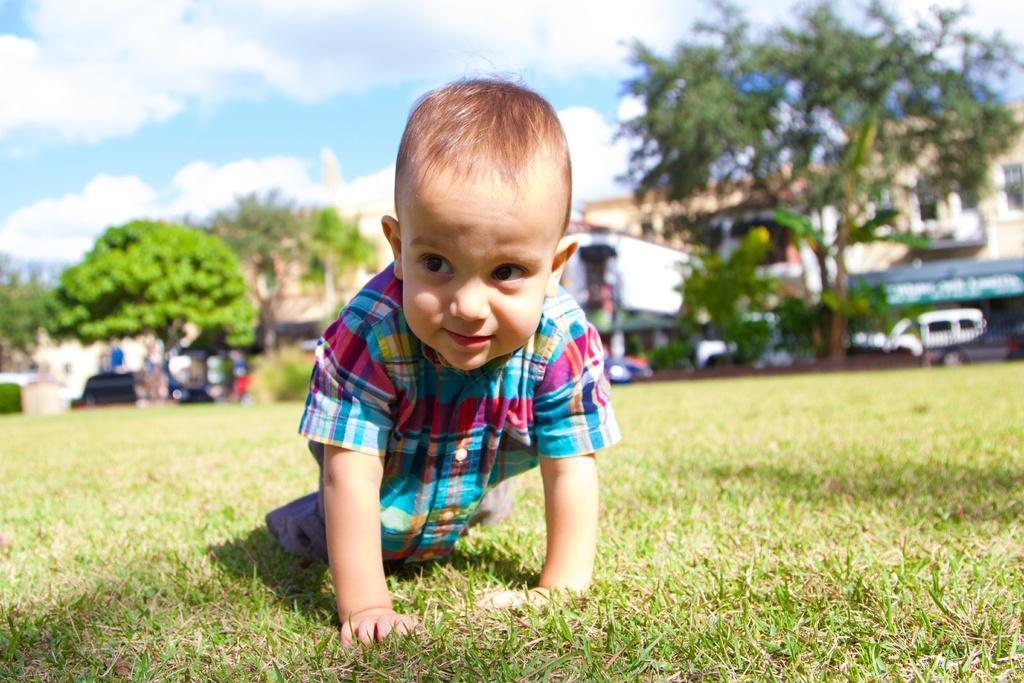What is the main subject of the image? The main subject of the image is a kid on the ground. What can be seen in the background of the image? There are buildings, trees, and the sky visible in the background of the image. What type of crops is the farmer growing on the plot in the image? There is no farmer or plot present in the image; it features a kid on the ground with buildings, trees, and the sky in the background. 